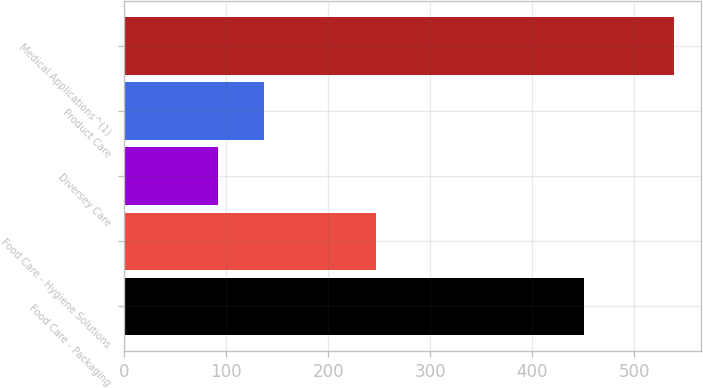Convert chart to OTSL. <chart><loc_0><loc_0><loc_500><loc_500><bar_chart><fcel>Food Care - Packaging<fcel>Food Care - Hygiene Solutions<fcel>Diversey Care<fcel>Product Care<fcel>Medical Applications^(1)<nl><fcel>451<fcel>247<fcel>92<fcel>136.7<fcel>539<nl></chart> 